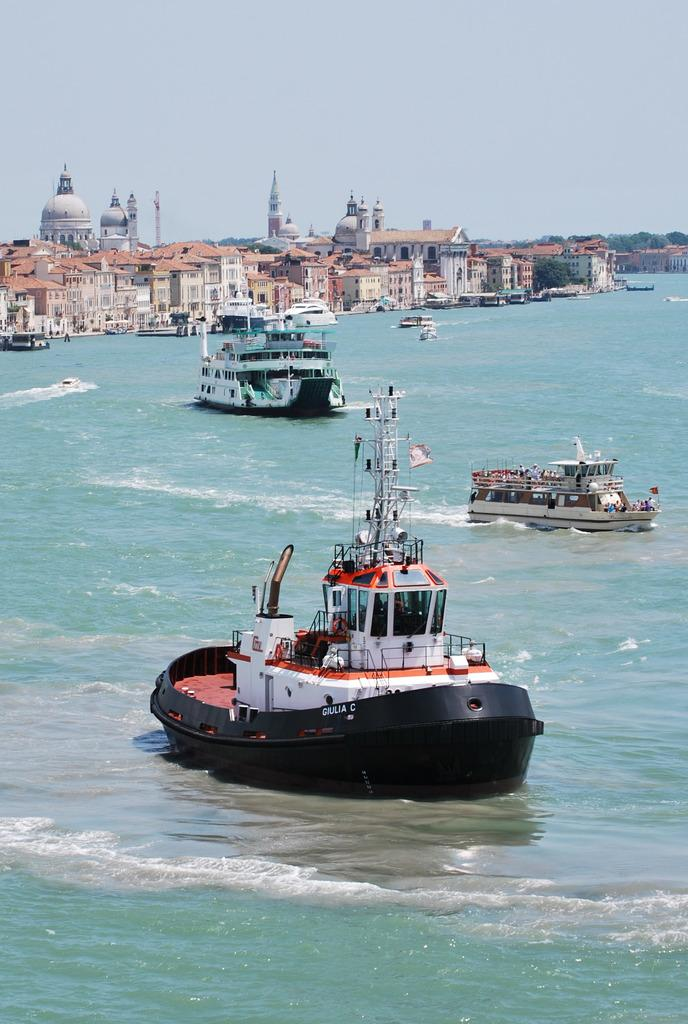What type of structures can be seen in the image? There are many buildings in the image. What natural feature is visible in the image? There are many trees in the image. What is happening on the water in the image? There are ships sailing on the sea in the image. What grade of wood is used to build the ships in the image? There is no information about the grade of wood used to build the ships in the image. 